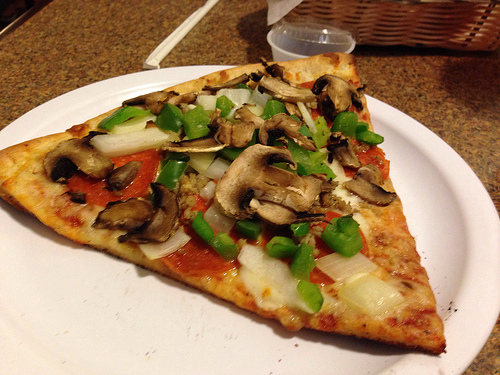Please provide the bounding box coordinate of the region this sentence describes: the unopened straw. The region containing an unopened straw is best represented by the coordinates [0.25, 0.12, 0.48, 0.26]. 